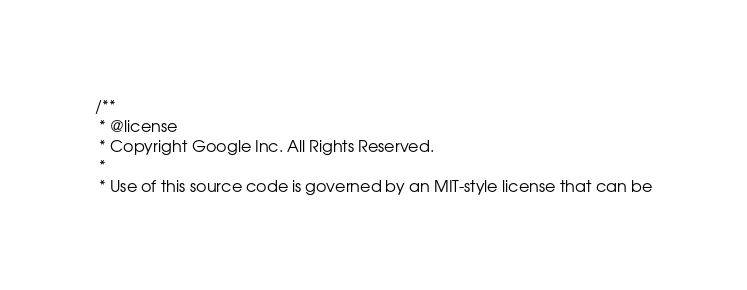Convert code to text. <code><loc_0><loc_0><loc_500><loc_500><_JavaScript_>/**
 * @license
 * Copyright Google Inc. All Rights Reserved.
 *
 * Use of this source code is governed by an MIT-style license that can be</code> 